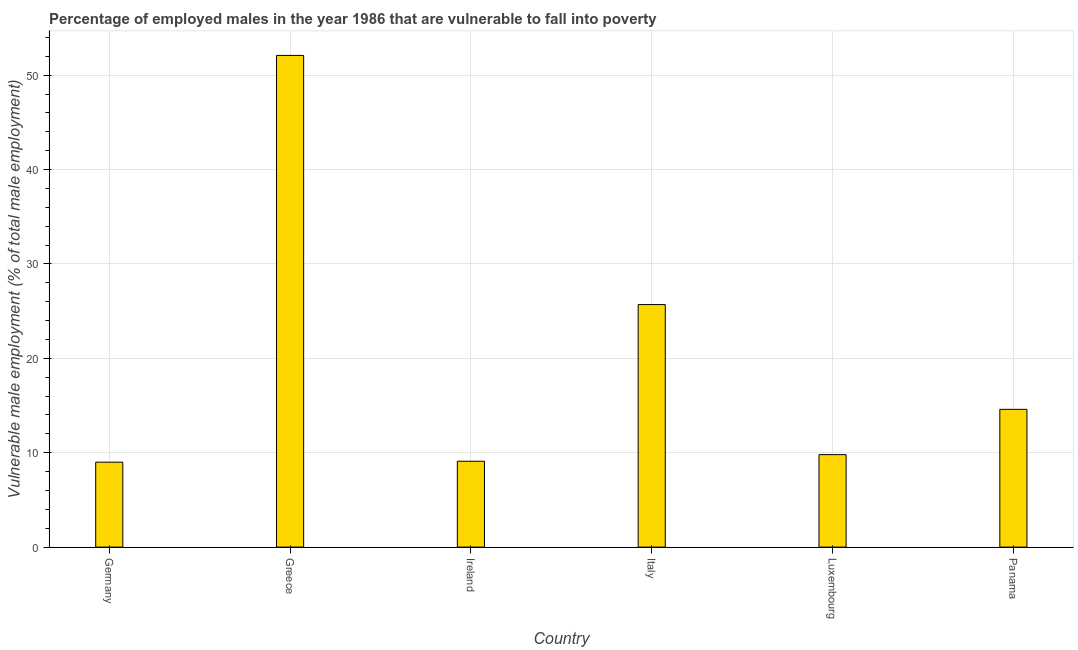Does the graph contain any zero values?
Offer a terse response. No. Does the graph contain grids?
Offer a terse response. Yes. What is the title of the graph?
Make the answer very short. Percentage of employed males in the year 1986 that are vulnerable to fall into poverty. What is the label or title of the X-axis?
Provide a succinct answer. Country. What is the label or title of the Y-axis?
Offer a very short reply. Vulnerable male employment (% of total male employment). What is the percentage of employed males who are vulnerable to fall into poverty in Italy?
Your answer should be compact. 25.7. Across all countries, what is the maximum percentage of employed males who are vulnerable to fall into poverty?
Offer a terse response. 52.1. In which country was the percentage of employed males who are vulnerable to fall into poverty maximum?
Your answer should be very brief. Greece. In which country was the percentage of employed males who are vulnerable to fall into poverty minimum?
Your answer should be very brief. Germany. What is the sum of the percentage of employed males who are vulnerable to fall into poverty?
Your response must be concise. 120.3. What is the difference between the percentage of employed males who are vulnerable to fall into poverty in Greece and Ireland?
Your answer should be compact. 43. What is the average percentage of employed males who are vulnerable to fall into poverty per country?
Offer a very short reply. 20.05. What is the median percentage of employed males who are vulnerable to fall into poverty?
Your response must be concise. 12.2. In how many countries, is the percentage of employed males who are vulnerable to fall into poverty greater than 52 %?
Give a very brief answer. 1. What is the ratio of the percentage of employed males who are vulnerable to fall into poverty in Italy to that in Panama?
Make the answer very short. 1.76. What is the difference between the highest and the second highest percentage of employed males who are vulnerable to fall into poverty?
Ensure brevity in your answer.  26.4. What is the difference between the highest and the lowest percentage of employed males who are vulnerable to fall into poverty?
Keep it short and to the point. 43.1. In how many countries, is the percentage of employed males who are vulnerable to fall into poverty greater than the average percentage of employed males who are vulnerable to fall into poverty taken over all countries?
Provide a short and direct response. 2. How many bars are there?
Keep it short and to the point. 6. How many countries are there in the graph?
Make the answer very short. 6. What is the difference between two consecutive major ticks on the Y-axis?
Give a very brief answer. 10. What is the Vulnerable male employment (% of total male employment) of Greece?
Offer a terse response. 52.1. What is the Vulnerable male employment (% of total male employment) of Ireland?
Keep it short and to the point. 9.1. What is the Vulnerable male employment (% of total male employment) of Italy?
Keep it short and to the point. 25.7. What is the Vulnerable male employment (% of total male employment) of Luxembourg?
Your response must be concise. 9.8. What is the Vulnerable male employment (% of total male employment) of Panama?
Your answer should be compact. 14.6. What is the difference between the Vulnerable male employment (% of total male employment) in Germany and Greece?
Your response must be concise. -43.1. What is the difference between the Vulnerable male employment (% of total male employment) in Germany and Italy?
Your answer should be compact. -16.7. What is the difference between the Vulnerable male employment (% of total male employment) in Greece and Ireland?
Give a very brief answer. 43. What is the difference between the Vulnerable male employment (% of total male employment) in Greece and Italy?
Your answer should be compact. 26.4. What is the difference between the Vulnerable male employment (% of total male employment) in Greece and Luxembourg?
Make the answer very short. 42.3. What is the difference between the Vulnerable male employment (% of total male employment) in Greece and Panama?
Your answer should be compact. 37.5. What is the difference between the Vulnerable male employment (% of total male employment) in Ireland and Italy?
Give a very brief answer. -16.6. What is the difference between the Vulnerable male employment (% of total male employment) in Ireland and Panama?
Your answer should be compact. -5.5. What is the difference between the Vulnerable male employment (% of total male employment) in Luxembourg and Panama?
Your answer should be very brief. -4.8. What is the ratio of the Vulnerable male employment (% of total male employment) in Germany to that in Greece?
Make the answer very short. 0.17. What is the ratio of the Vulnerable male employment (% of total male employment) in Germany to that in Ireland?
Your answer should be very brief. 0.99. What is the ratio of the Vulnerable male employment (% of total male employment) in Germany to that in Italy?
Your answer should be very brief. 0.35. What is the ratio of the Vulnerable male employment (% of total male employment) in Germany to that in Luxembourg?
Make the answer very short. 0.92. What is the ratio of the Vulnerable male employment (% of total male employment) in Germany to that in Panama?
Your answer should be compact. 0.62. What is the ratio of the Vulnerable male employment (% of total male employment) in Greece to that in Ireland?
Ensure brevity in your answer.  5.72. What is the ratio of the Vulnerable male employment (% of total male employment) in Greece to that in Italy?
Ensure brevity in your answer.  2.03. What is the ratio of the Vulnerable male employment (% of total male employment) in Greece to that in Luxembourg?
Make the answer very short. 5.32. What is the ratio of the Vulnerable male employment (% of total male employment) in Greece to that in Panama?
Offer a very short reply. 3.57. What is the ratio of the Vulnerable male employment (% of total male employment) in Ireland to that in Italy?
Your answer should be compact. 0.35. What is the ratio of the Vulnerable male employment (% of total male employment) in Ireland to that in Luxembourg?
Provide a short and direct response. 0.93. What is the ratio of the Vulnerable male employment (% of total male employment) in Ireland to that in Panama?
Provide a short and direct response. 0.62. What is the ratio of the Vulnerable male employment (% of total male employment) in Italy to that in Luxembourg?
Your response must be concise. 2.62. What is the ratio of the Vulnerable male employment (% of total male employment) in Italy to that in Panama?
Give a very brief answer. 1.76. What is the ratio of the Vulnerable male employment (% of total male employment) in Luxembourg to that in Panama?
Provide a succinct answer. 0.67. 